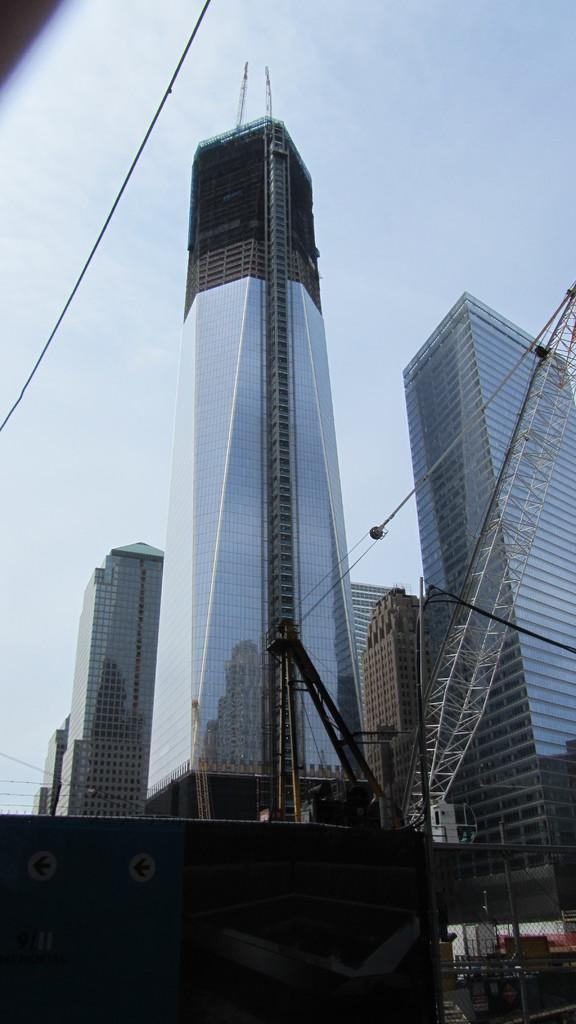What is located in the foreground of the image? There is a shelter and fencing in the foreground of the image. What can be seen in the middle of the image? There appears to be a crane in the middle of the image. What type of structures are visible in the background of the image? There are skyscrapers in the background of the image. What is visible in the sky in the background of the image? The sky is visible in the background of the image. Can you tell me how many volcanoes are visible in the image? There are no volcanoes present in the image. What type of coastline can be seen in the image? There is no coastline visible in the image; it features a shelter, fencing, a crane, skyscrapers, and the sky. 